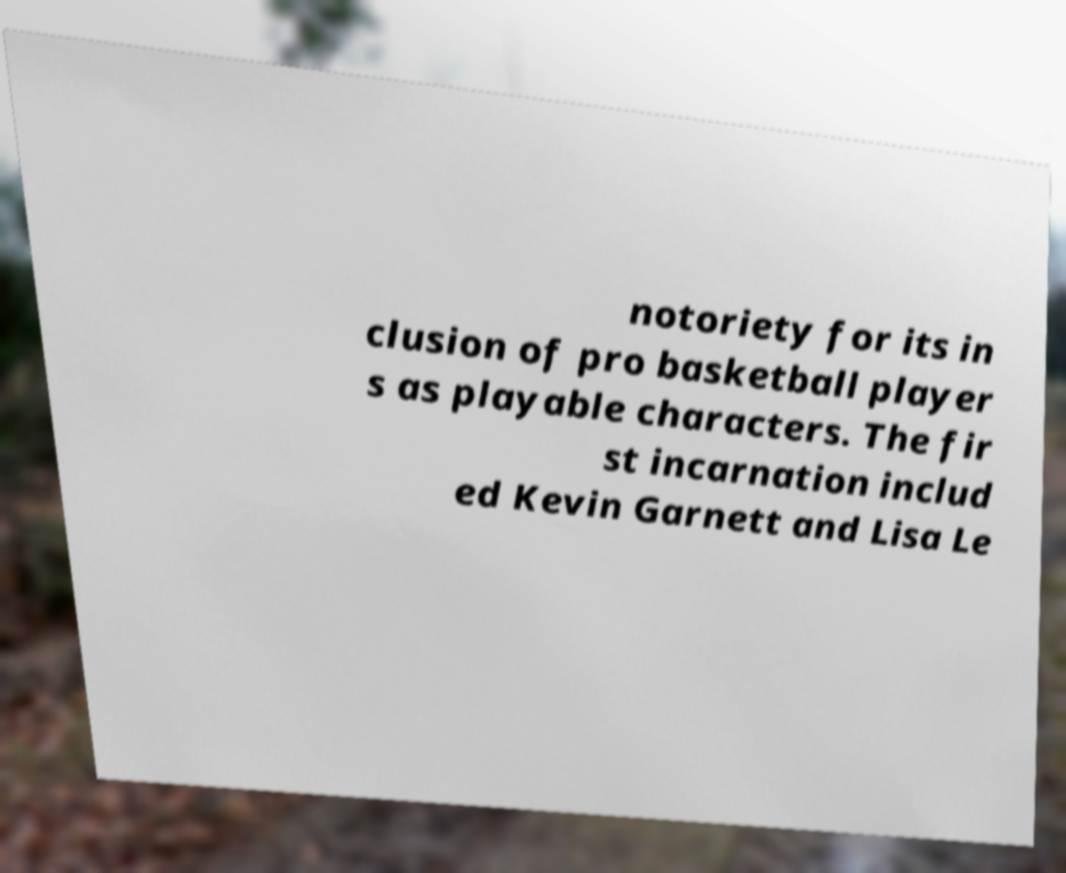Can you accurately transcribe the text from the provided image for me? notoriety for its in clusion of pro basketball player s as playable characters. The fir st incarnation includ ed Kevin Garnett and Lisa Le 